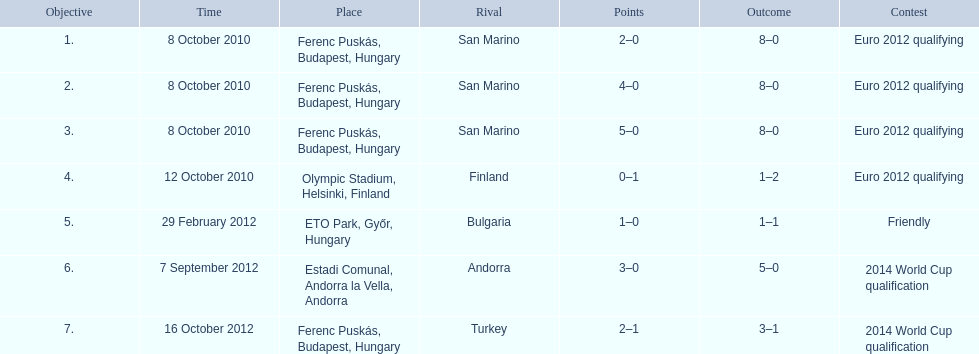How many non-qualifying games did he score in? 1. 